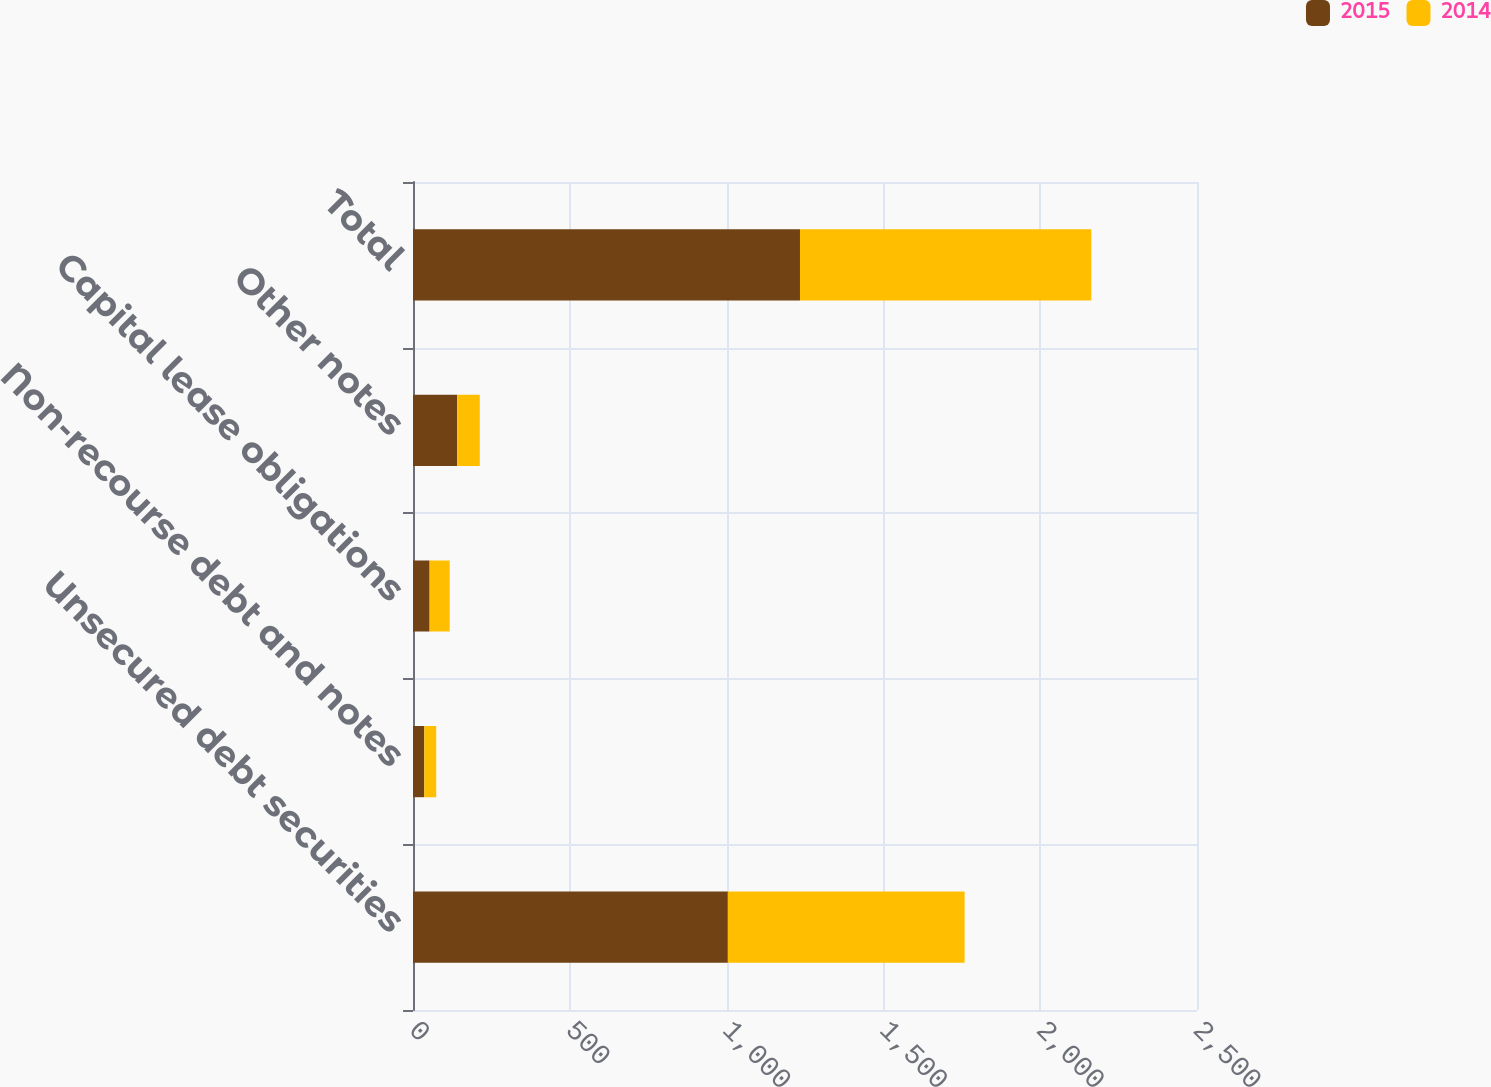Convert chart to OTSL. <chart><loc_0><loc_0><loc_500><loc_500><stacked_bar_chart><ecel><fcel>Unsecured debt securities<fcel>Non-recourse debt and notes<fcel>Capital lease obligations<fcel>Other notes<fcel>Total<nl><fcel>2015<fcel>1004<fcel>36<fcel>53<fcel>141<fcel>1234<nl><fcel>2014<fcel>755<fcel>38<fcel>64<fcel>72<fcel>929<nl></chart> 